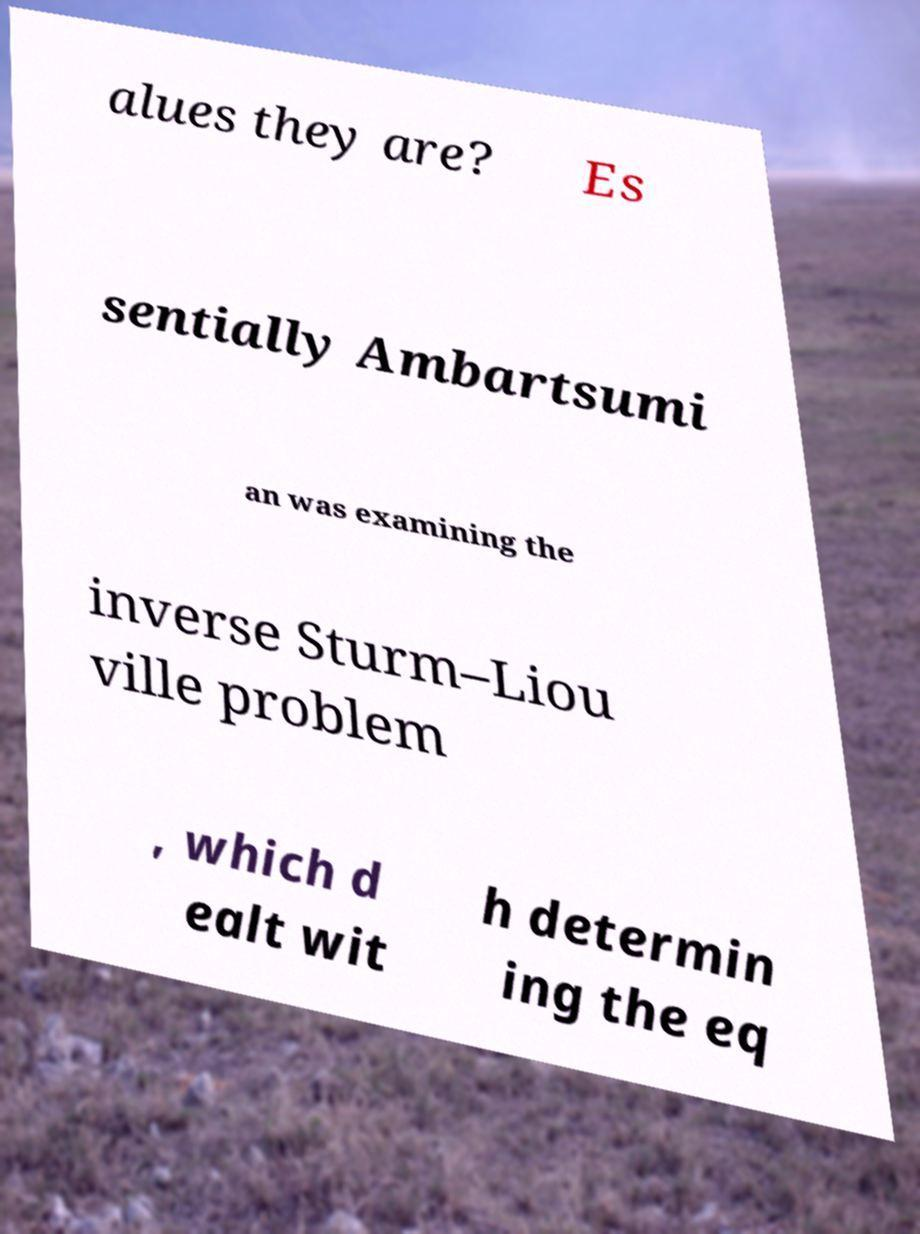Could you extract and type out the text from this image? alues they are? Es sentially Ambartsumi an was examining the inverse Sturm–Liou ville problem , which d ealt wit h determin ing the eq 